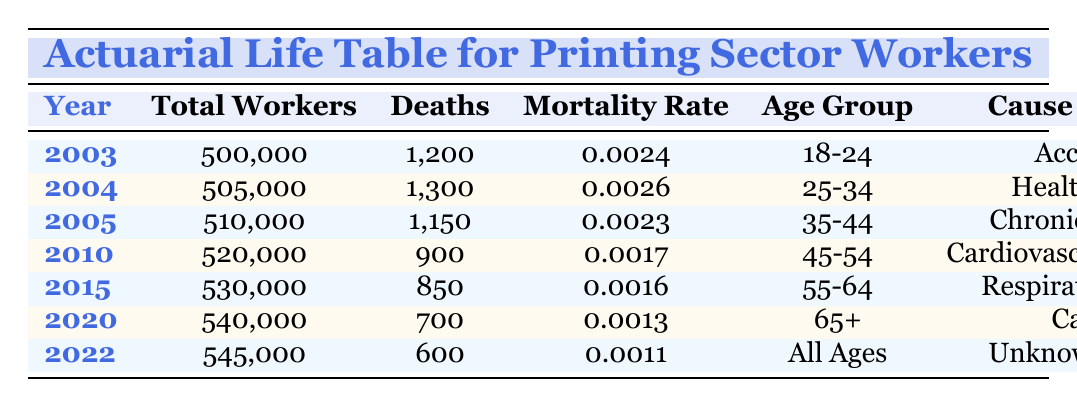What was the mortality rate of workers in the year 2004? The table provides the mortality rate specifically for the year 2004, which is clearly listed under that year in the Mortality Rate column. For 2004, it shows 0.0026.
Answer: 0.0026 In which age group did the highest number of deaths occur in 2003? By looking at the row for the year 2003, we see that the age group is 18-24 and the number of deaths is 1,200. This information is directly referenced in the table.
Answer: 18-24 What is the total number of deaths recorded from 2010 to 2022? To find the total deaths from 2010 to 2022, we need to sum the deaths for those years: 900 (2010) + 850 (2015) + 700 (2020) + 600 (2022) = 3050.
Answer: 3050 Is the mortality rate for workers aged 65 and older lower than the mortality rate for workers aged 25-34? The mortality rate for workers aged 65 and older in 2020 is 0.0013, while for workers aged 25-34 in 2004 it is 0.0026. Since 0.0013 is less than 0.0026, the statement is true.
Answer: Yes What percentage of the total workers were reported as deaths in the year 2020? For the year 2020, the total number of workers is 540,000 and the deaths registered are 700. To find the percentage, we use the formula: (700 / 540,000) * 100 = 0.1296%. So, the percentage is approximately 0.13%.
Answer: 0.13% Which cause of death was recorded for the age group 45-54? The table indicates that for the year 2010, the age group of 45-54 has the cause of death listed as Cardiovascular Diseases. This is directly stated under cause of death for that age group in the table.
Answer: Cardiovascular Diseases How many deaths occurred in the year 2022 compared to 2003? In 2022, the table shows the number of deaths as 600, while in 2003, it was 1,200. To find the difference: 1,200 - 600 = 600. Therefore, there were 600 fewer deaths in 2022 compared to 2003.
Answer: 600 What trend can be observed regarding mortality rates from 2003 to 2022? By analyzing the Mortality Rates across the years provided, we can see that they have generally decreased from 0.0024 in 2003 to 0.0011 in 2022. This indicates an overall downward trend in mortality rates for workers in the printing sector over this period.
Answer: Decreasing trend 